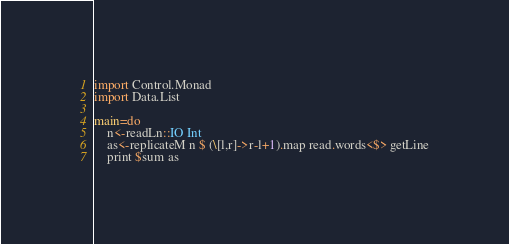<code> <loc_0><loc_0><loc_500><loc_500><_Haskell_>import Control.Monad
import Data.List

main=do
    n<-readLn::IO Int
    as<-replicateM n $ (\[l,r]->r-l+1).map read.words<$> getLine
    print $sum as</code> 